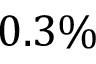Convert formula to latex. <formula><loc_0><loc_0><loc_500><loc_500>0 . 3 \%</formula> 